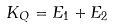Convert formula to latex. <formula><loc_0><loc_0><loc_500><loc_500>K _ { Q } = E _ { 1 } + E _ { 2 }</formula> 